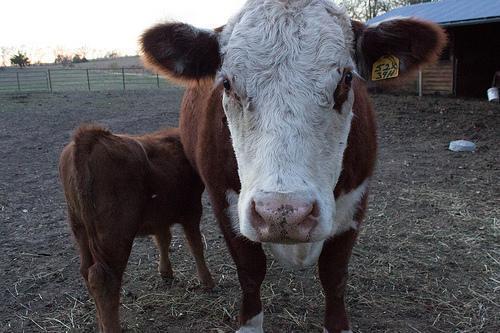How many cows are shown?
Give a very brief answer. 2. 